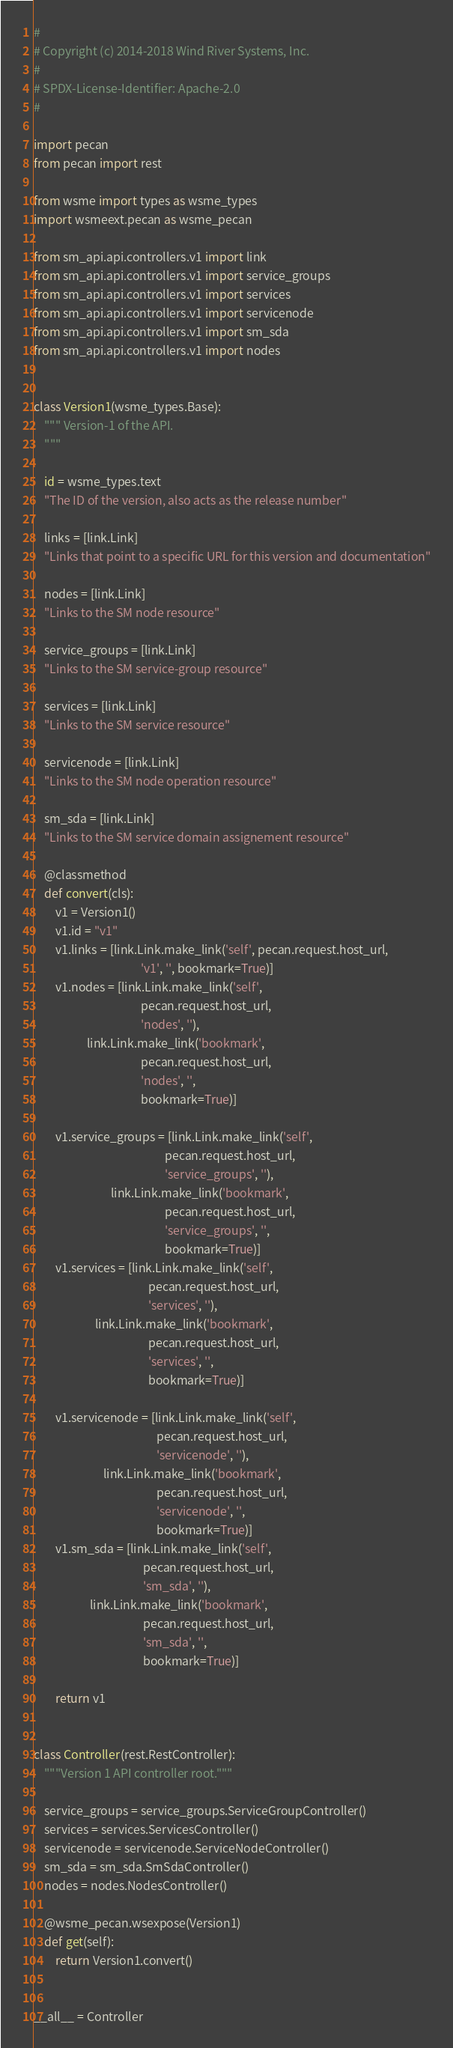<code> <loc_0><loc_0><loc_500><loc_500><_Python_>#
# Copyright (c) 2014-2018 Wind River Systems, Inc.
#
# SPDX-License-Identifier: Apache-2.0
#

import pecan
from pecan import rest

from wsme import types as wsme_types
import wsmeext.pecan as wsme_pecan

from sm_api.api.controllers.v1 import link
from sm_api.api.controllers.v1 import service_groups
from sm_api.api.controllers.v1 import services
from sm_api.api.controllers.v1 import servicenode
from sm_api.api.controllers.v1 import sm_sda
from sm_api.api.controllers.v1 import nodes


class Version1(wsme_types.Base):
    """ Version-1 of the API.
    """

    id = wsme_types.text
    "The ID of the version, also acts as the release number"

    links = [link.Link]
    "Links that point to a specific URL for this version and documentation"

    nodes = [link.Link]
    "Links to the SM node resource"

    service_groups = [link.Link]
    "Links to the SM service-group resource"

    services = [link.Link]
    "Links to the SM service resource"

    servicenode = [link.Link]
    "Links to the SM node operation resource"

    sm_sda = [link.Link]
    "Links to the SM service domain assignement resource"

    @classmethod
    def convert(cls):
        v1 = Version1()
        v1.id = "v1"
        v1.links = [link.Link.make_link('self', pecan.request.host_url,
                                        'v1', '', bookmark=True)]
        v1.nodes = [link.Link.make_link('self',
                                        pecan.request.host_url,
                                        'nodes', ''),
                    link.Link.make_link('bookmark',
                                        pecan.request.host_url,
                                        'nodes', '',
                                        bookmark=True)]

        v1.service_groups = [link.Link.make_link('self',
                                                 pecan.request.host_url,
                                                 'service_groups', ''),
                             link.Link.make_link('bookmark',
                                                 pecan.request.host_url,
                                                 'service_groups', '',
                                                 bookmark=True)]
        v1.services = [link.Link.make_link('self',
                                           pecan.request.host_url,
                                           'services', ''),
                       link.Link.make_link('bookmark',
                                           pecan.request.host_url,
                                           'services', '',
                                           bookmark=True)]

        v1.servicenode = [link.Link.make_link('self',
                                              pecan.request.host_url,
                                              'servicenode', ''),
                          link.Link.make_link('bookmark',
                                              pecan.request.host_url,
                                              'servicenode', '',
                                              bookmark=True)]
        v1.sm_sda = [link.Link.make_link('self',
                                         pecan.request.host_url,
                                         'sm_sda', ''),
                     link.Link.make_link('bookmark',
                                         pecan.request.host_url,
                                         'sm_sda', '',
                                         bookmark=True)]

        return v1


class Controller(rest.RestController):
    """Version 1 API controller root."""

    service_groups = service_groups.ServiceGroupController()
    services = services.ServicesController()
    servicenode = servicenode.ServiceNodeController()
    sm_sda = sm_sda.SmSdaController()
    nodes = nodes.NodesController()

    @wsme_pecan.wsexpose(Version1)
    def get(self):
        return Version1.convert()


__all__ = Controller
</code> 